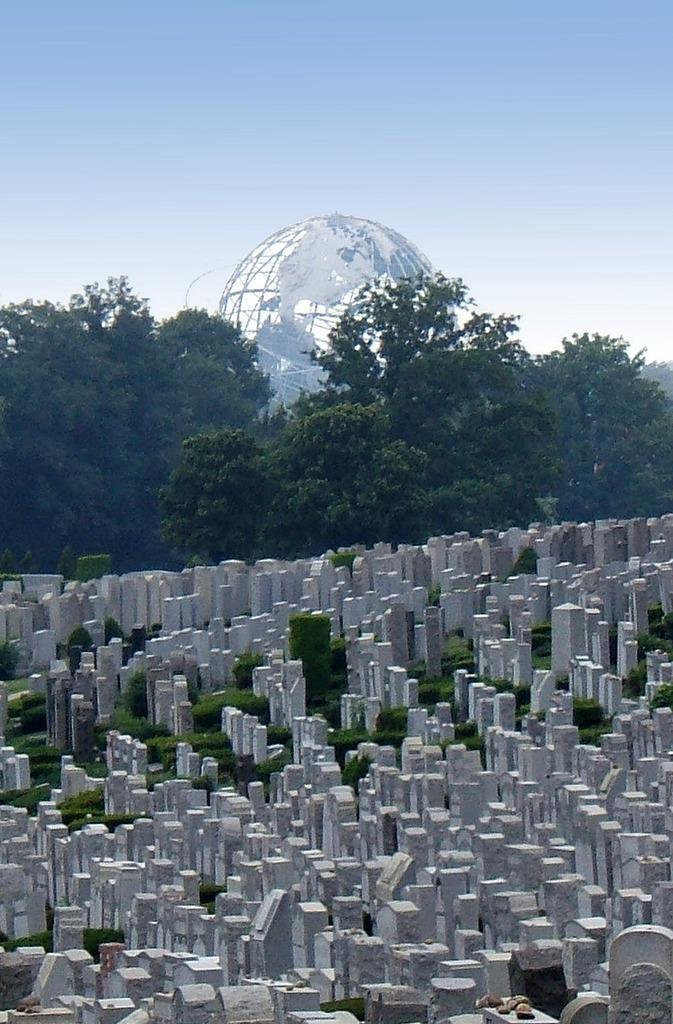Describe this image in one or two sentences. In this image there are so many stones on the ground. In the background there are trees and there is a globe in between the trees. At the top there is sky. On the ground there is grass and stones. 